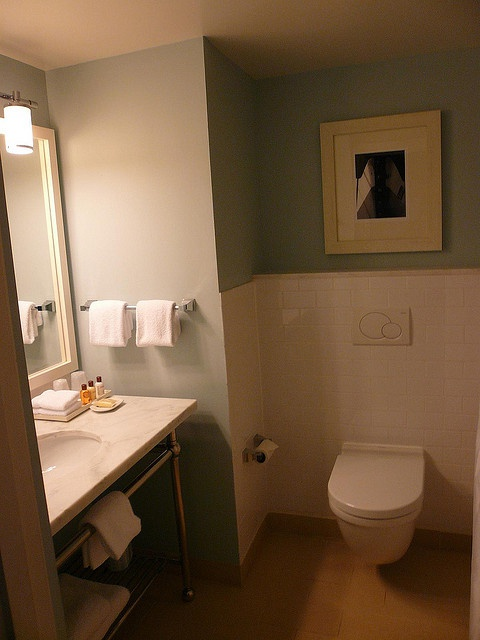Describe the objects in this image and their specific colors. I can see toilet in tan, gray, maroon, and black tones, sink in tan tones, cup in tan tones, and cup in tan tones in this image. 